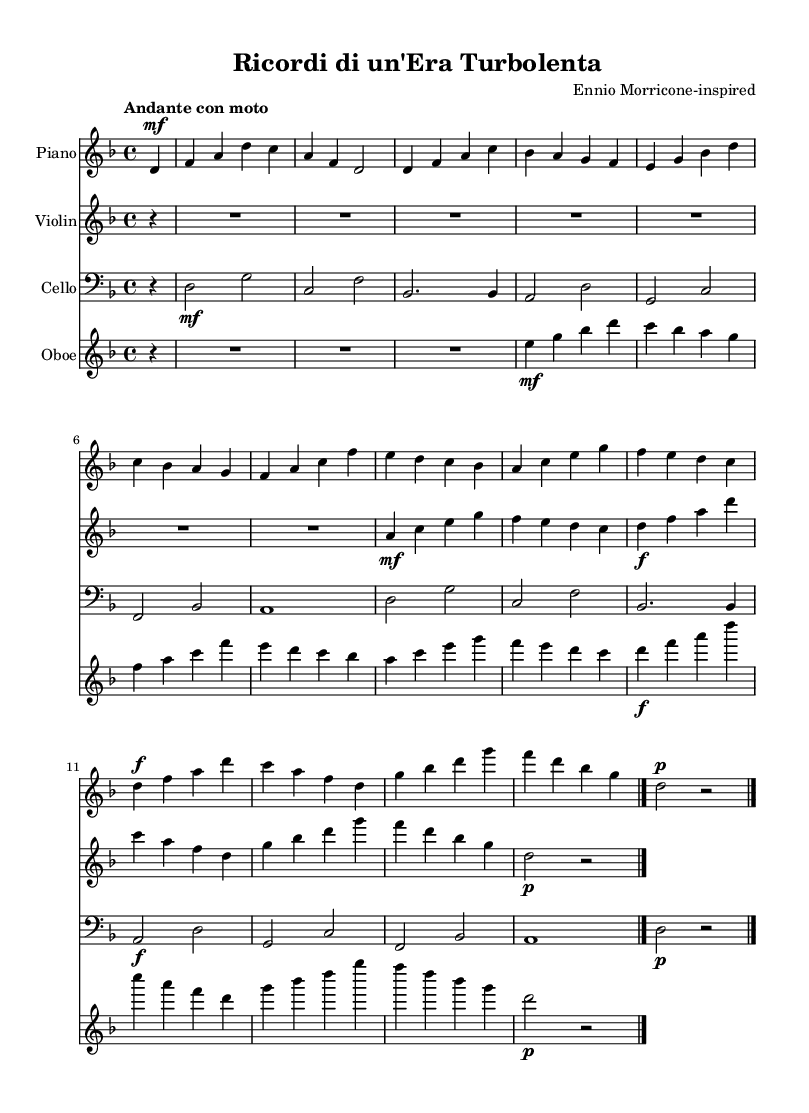What is the key signature of this music? The key signature appears at the beginning of the score, which indicates D minor, having one flat, B flat.
Answer: D minor What is the time signature of this music? The time signature is located at the beginning of the staff and is indicated as 4/4, meaning there are four beats in each measure.
Answer: 4/4 What is the tempo marking of this music? The tempo marking, found at the start of the piece, reads "Andante con moto," indicating a moderate tempo that is moving.
Answer: Andante con moto How many instruments are featured in this score? By counting the distinct staves labeled at the beginning of the sections, we find there are four instruments: Piano, Violin, Cello, and Oboe.
Answer: Four Which instrument has the highest pitch in this piece? By analyzing the notes written for each instrument, the Violin typically plays notes higher than the other instruments across the score, especially in the sections provided.
Answer: Violin What dynamic marking is present for the piano part? In the piano section, the dynamic marking is indicated as "mf," which stands for mezzo-forte, meaning moderately loud.
Answer: mf What is the last note played by the cello? The cello part ends with a whole note marked "d," meaning the last note it plays in this composition is the note D.
Answer: d 